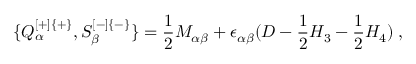Convert formula to latex. <formula><loc_0><loc_0><loc_500><loc_500>\{ Q _ { \alpha } ^ { [ + ] \{ + \} } , S _ { \beta } ^ { [ - ] \{ - \} } \} = { \frac { 1 } { 2 } } M _ { \alpha \beta } + \epsilon _ { \alpha \beta } ( D - { \frac { 1 } { 2 } } H _ { 3 } - { \frac { 1 } { 2 } } H _ { 4 } ) \, ,</formula> 